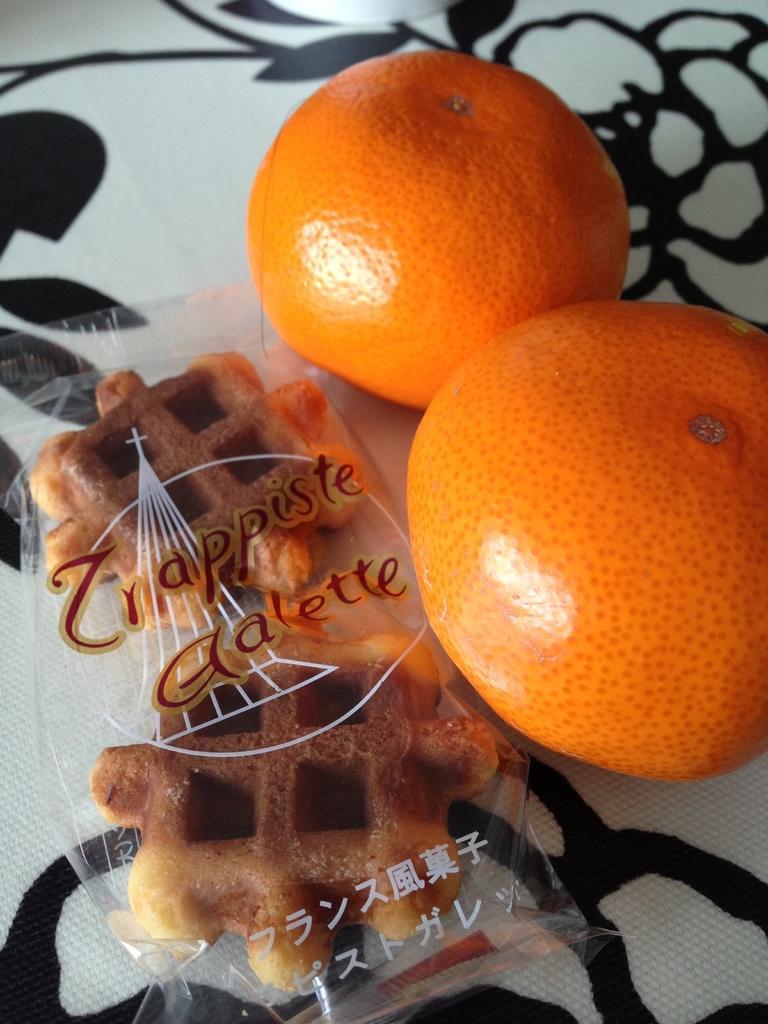Describe this image in one or two sentences. This image consists of food which is in the center. 